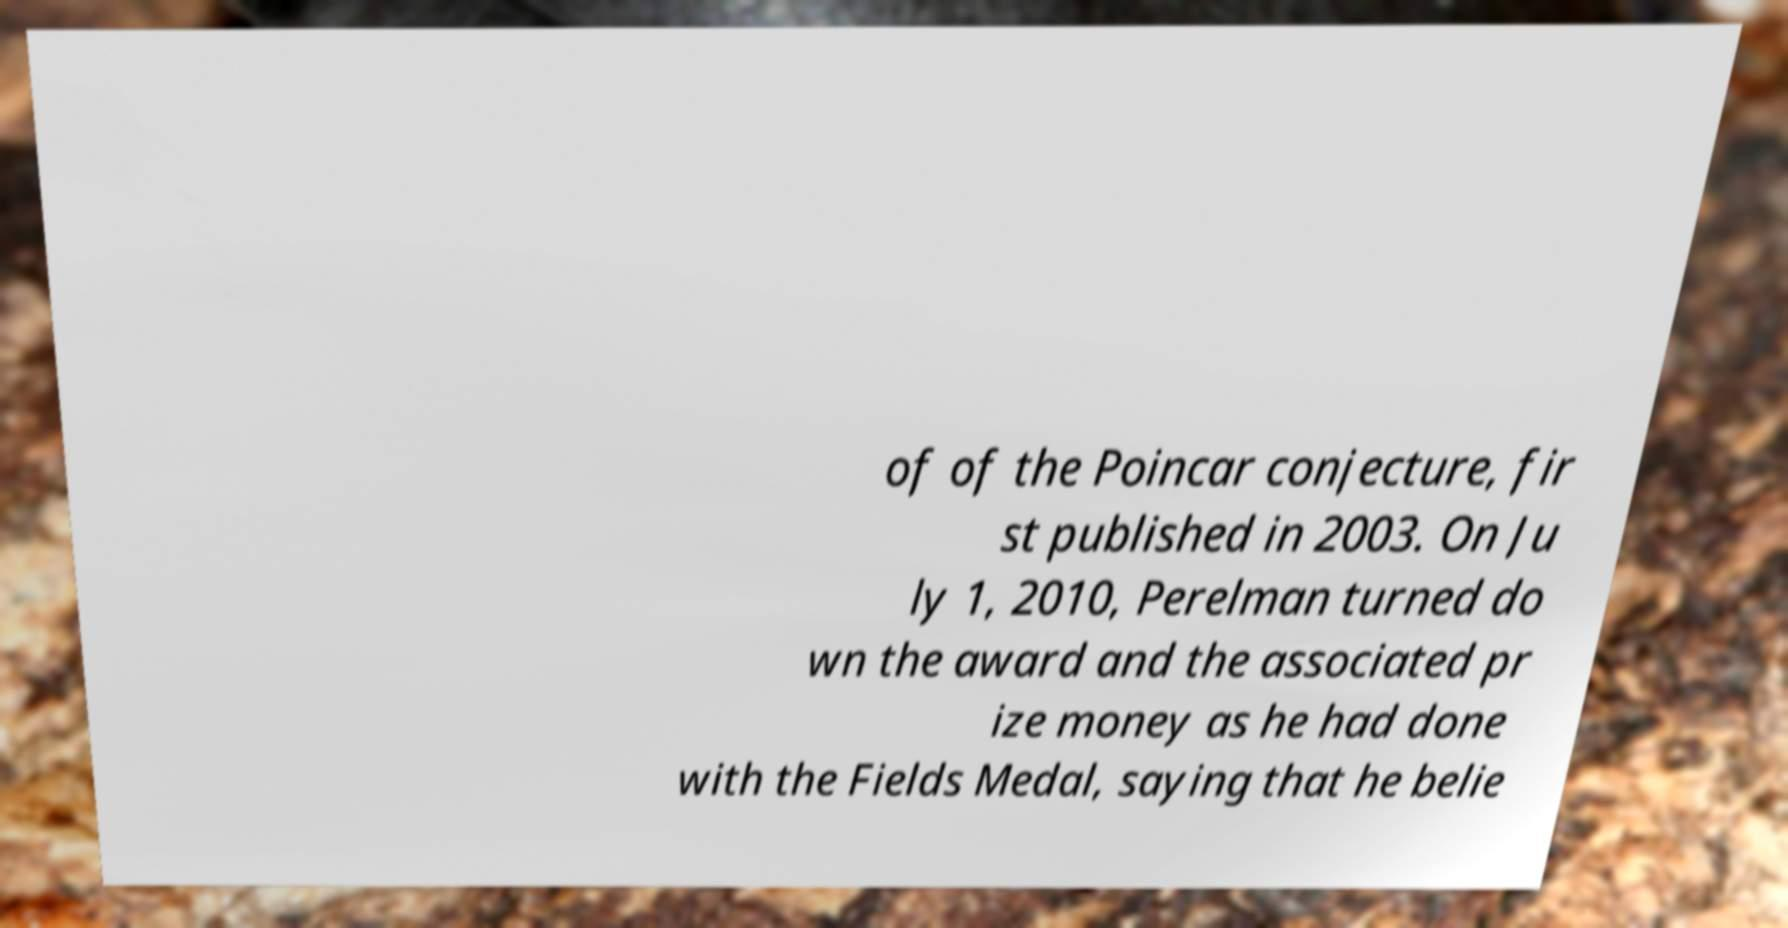There's text embedded in this image that I need extracted. Can you transcribe it verbatim? of of the Poincar conjecture, fir st published in 2003. On Ju ly 1, 2010, Perelman turned do wn the award and the associated pr ize money as he had done with the Fields Medal, saying that he belie 